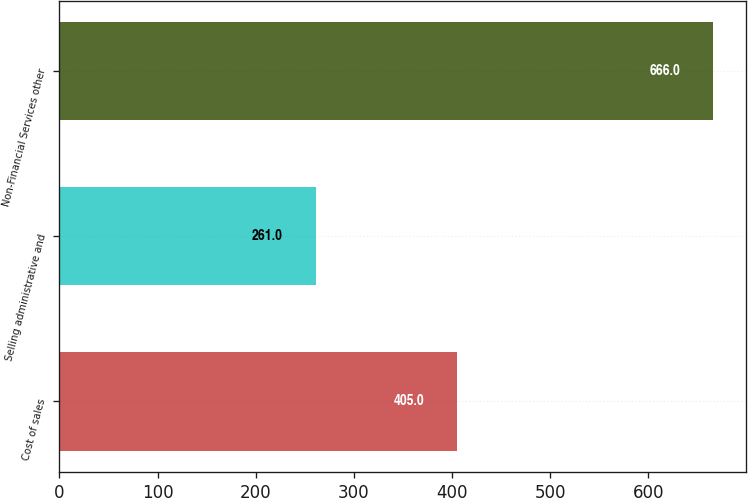Convert chart. <chart><loc_0><loc_0><loc_500><loc_500><bar_chart><fcel>Cost of sales<fcel>Selling administrative and<fcel>Non-Financial Services other<nl><fcel>405<fcel>261<fcel>666<nl></chart> 